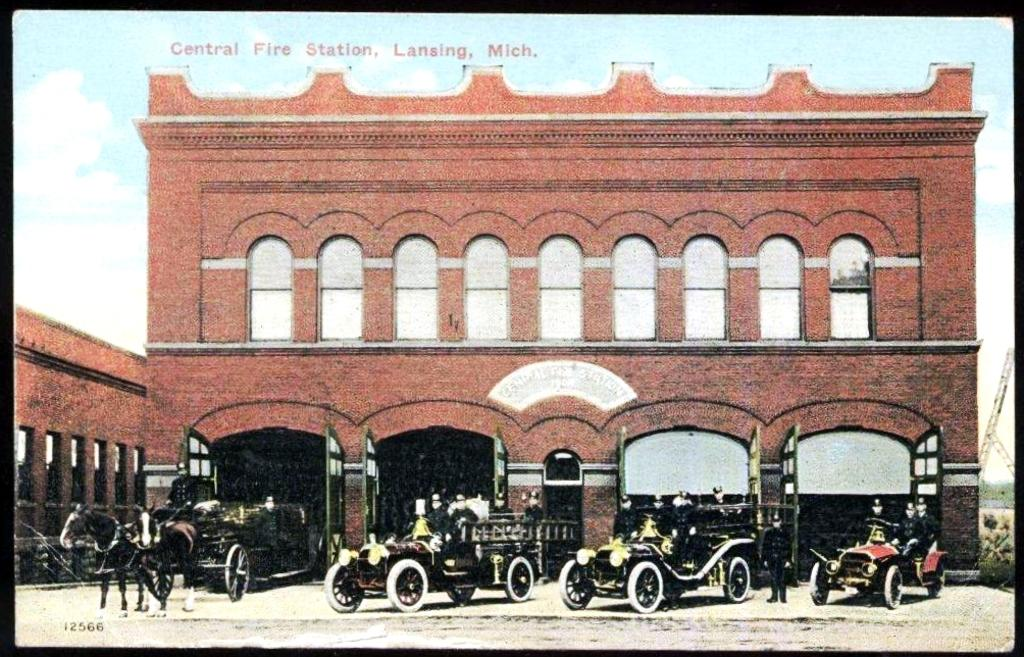What type of visual representation is shown in the image? The image is a poster. What types of transportation are depicted on the poster? There are vehicles on the poster. What specific vehicle can be seen on the poster? There is a cart on the poster. What animals are present on the poster? There are horses on the poster. What type of structure is visible on the poster? There is a building on the poster. What can be seen in the background of the poster? The sky is visible in the background of the poster. What brand of toothpaste is being advertised on the poster? There is no toothpaste or advertisement present on the poster; it features vehicles, a cart, horses, a building, and the sky. How many children are visible on the poster? There are no children present on the poster. 